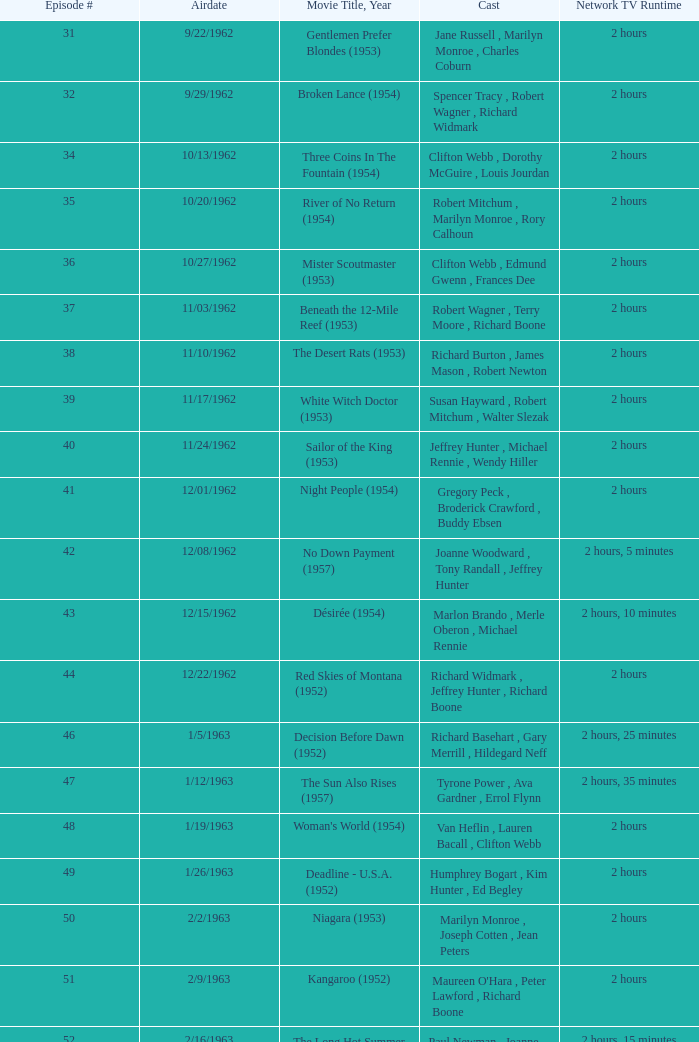What movie did dana wynter , mel ferrer , theodore bikel star in? Fraulein (1958). 